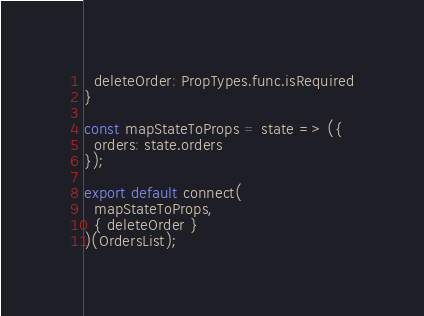<code> <loc_0><loc_0><loc_500><loc_500><_JavaScript_>  deleteOrder: PropTypes.func.isRequired
}

const mapStateToProps = state => ({
  orders: state.orders
});

export default connect(
  mapStateToProps,
  { deleteOrder }
)(OrdersList);
</code> 